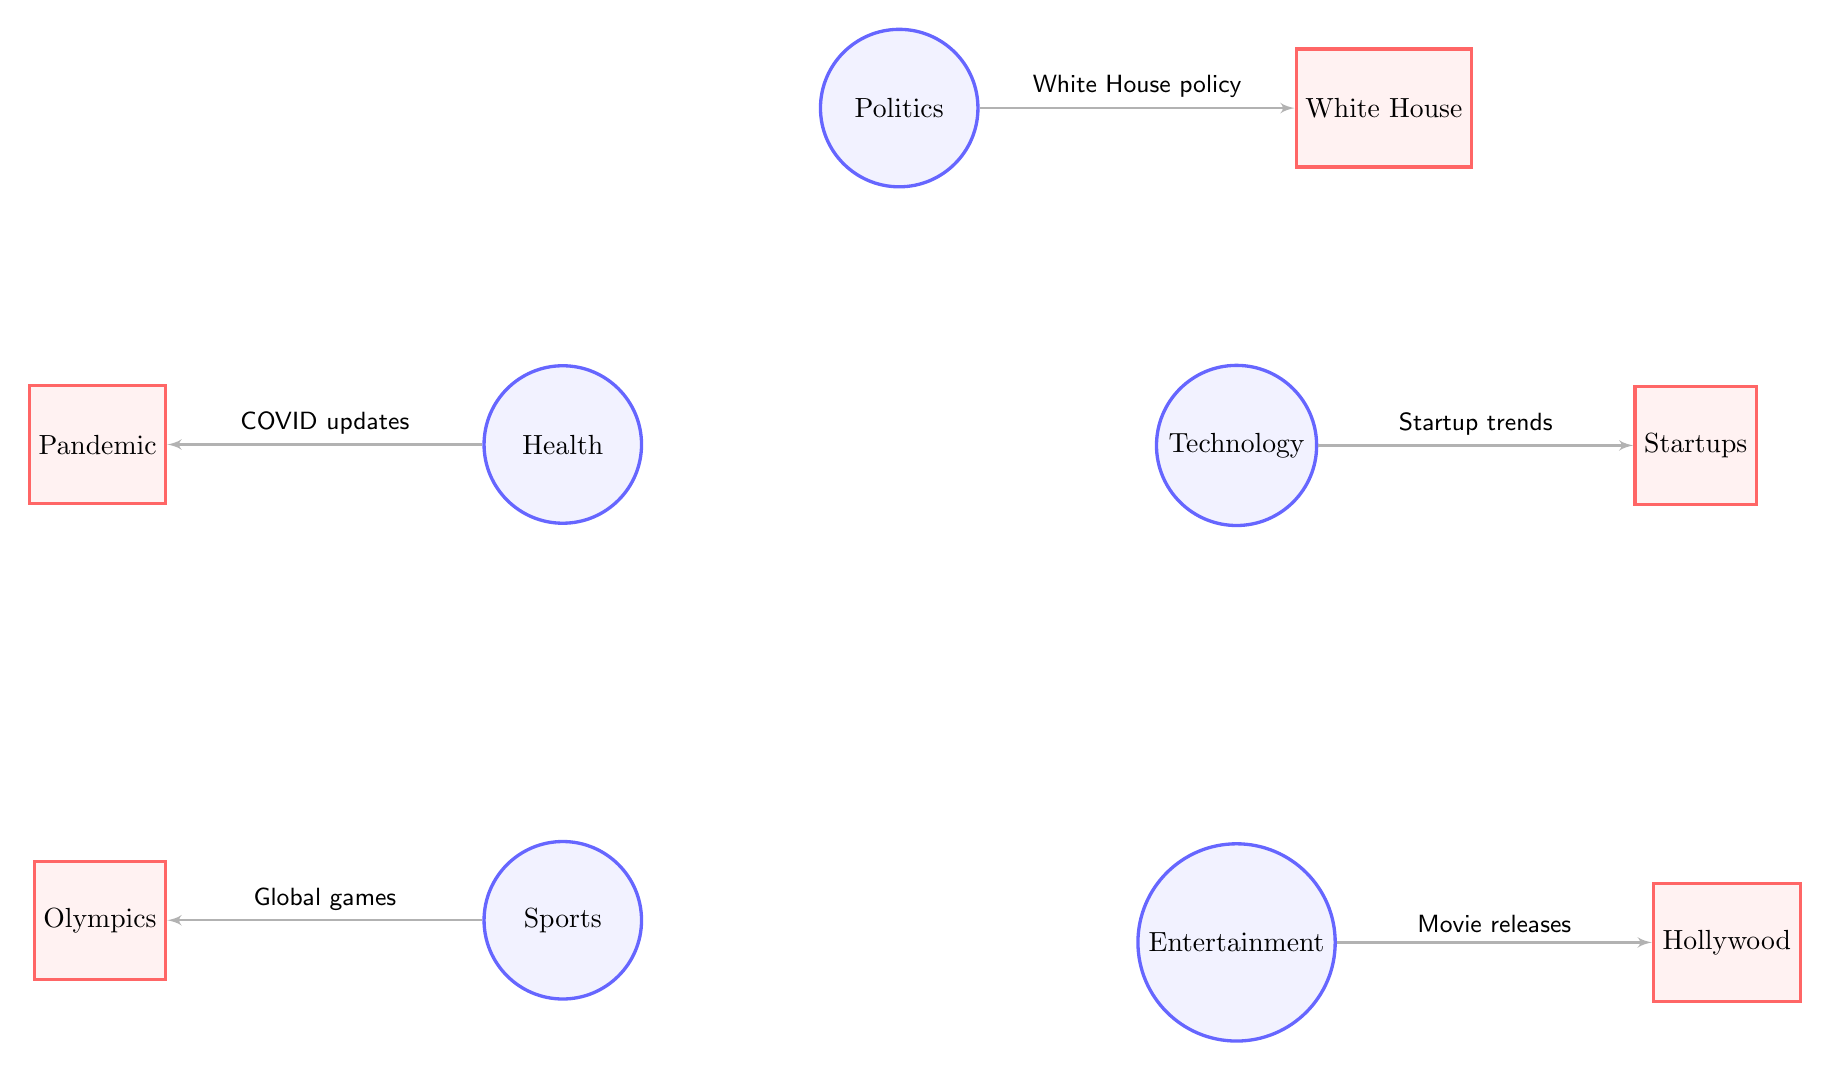What are the major news segments represented in the diagram? The diagram lists five major news segments: Politics, Technology, Health, Entertainment, and Sports. This information is directly visible as main nodes in the diagram.
Answer: Politics, Technology, Health, Entertainment, Sports Which sub-node is associated with Health? Below the main Health node, the sub-node Pandemic is directly connected. The diagram uses a clear layout where sub-nodes are placed underneath their corresponding main nodes.
Answer: Pandemic How many edges are depicted in the diagram? The diagram shows five edges connecting each main node to its respective sub-node, which indicates relationships. By counting the edges, we find there are five.
Answer: 5 What does the edge from Politics to White House represent? The edge between Politics and White House is labeled with the text "White House policy," which describes the relationship and indicates the specific focus of the Politics segment.
Answer: White House policy Which sub-node links to the Technology segment? The Technology main node is connected to the sub-node Startups via an edge, denoted by "Startup trends." This shows the relationship in terms of technological advancements.
Answer: Startups Which two sub-nodes are associated with Sports and what do they represent? The Sports node connects to the sub-node Olympics by an edge labeled "Global games." This illustrates the connection of Sports news to Olympic events.
Answer: Olympics If COVID updates are mentioned, which major segment does it belong to? The edge labeled "COVID updates" connects the Health segment to its sub-node Pandemic, clearly situating COVID updates under Health news.
Answer: Health What main node is located below Technology in the diagram? Directly beneath the Technology node is the Entertainment node, showing the hierarchical structure of news segments in the diagram.
Answer: Entertainment 